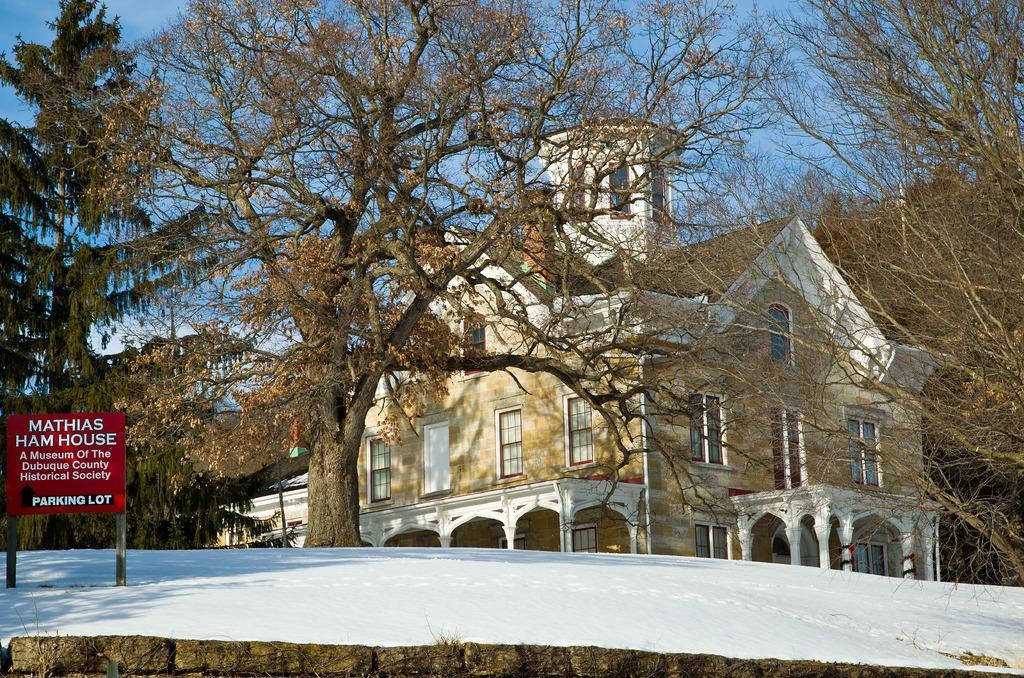What type of structure is present in the image? There is a building in the image. What is the condition of the ground in the image? The ground is covered with snow. What type of vegetation can be seen in the image? There are trees in the image. What is written on the board in the image? There is a board with text in the image. What is visible in the background of the image? The sky is visible in the image. What flavor of ice cream is being suggested on the board in the image? There is no ice cream or suggestion of a flavor present in the image. 